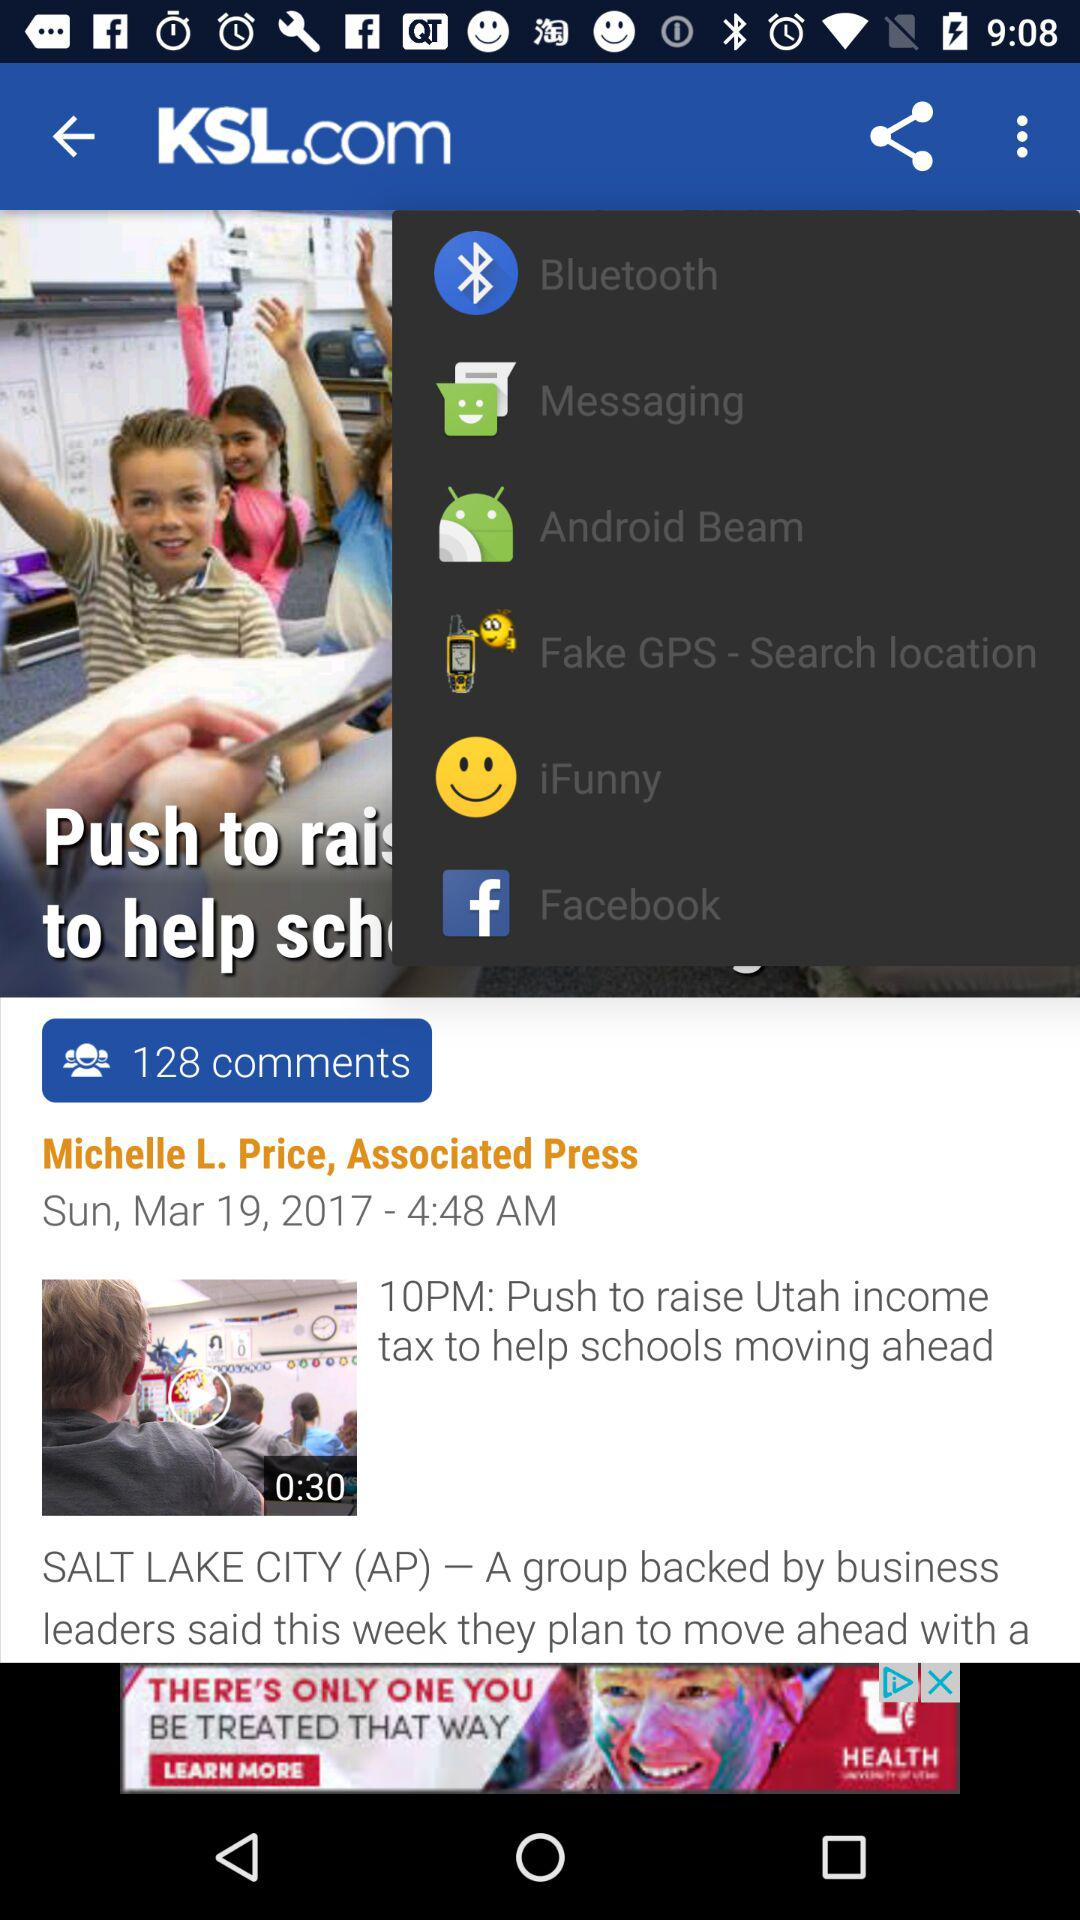When was this article last updated? This article was last updated on Sunday,March 19, 2017. 